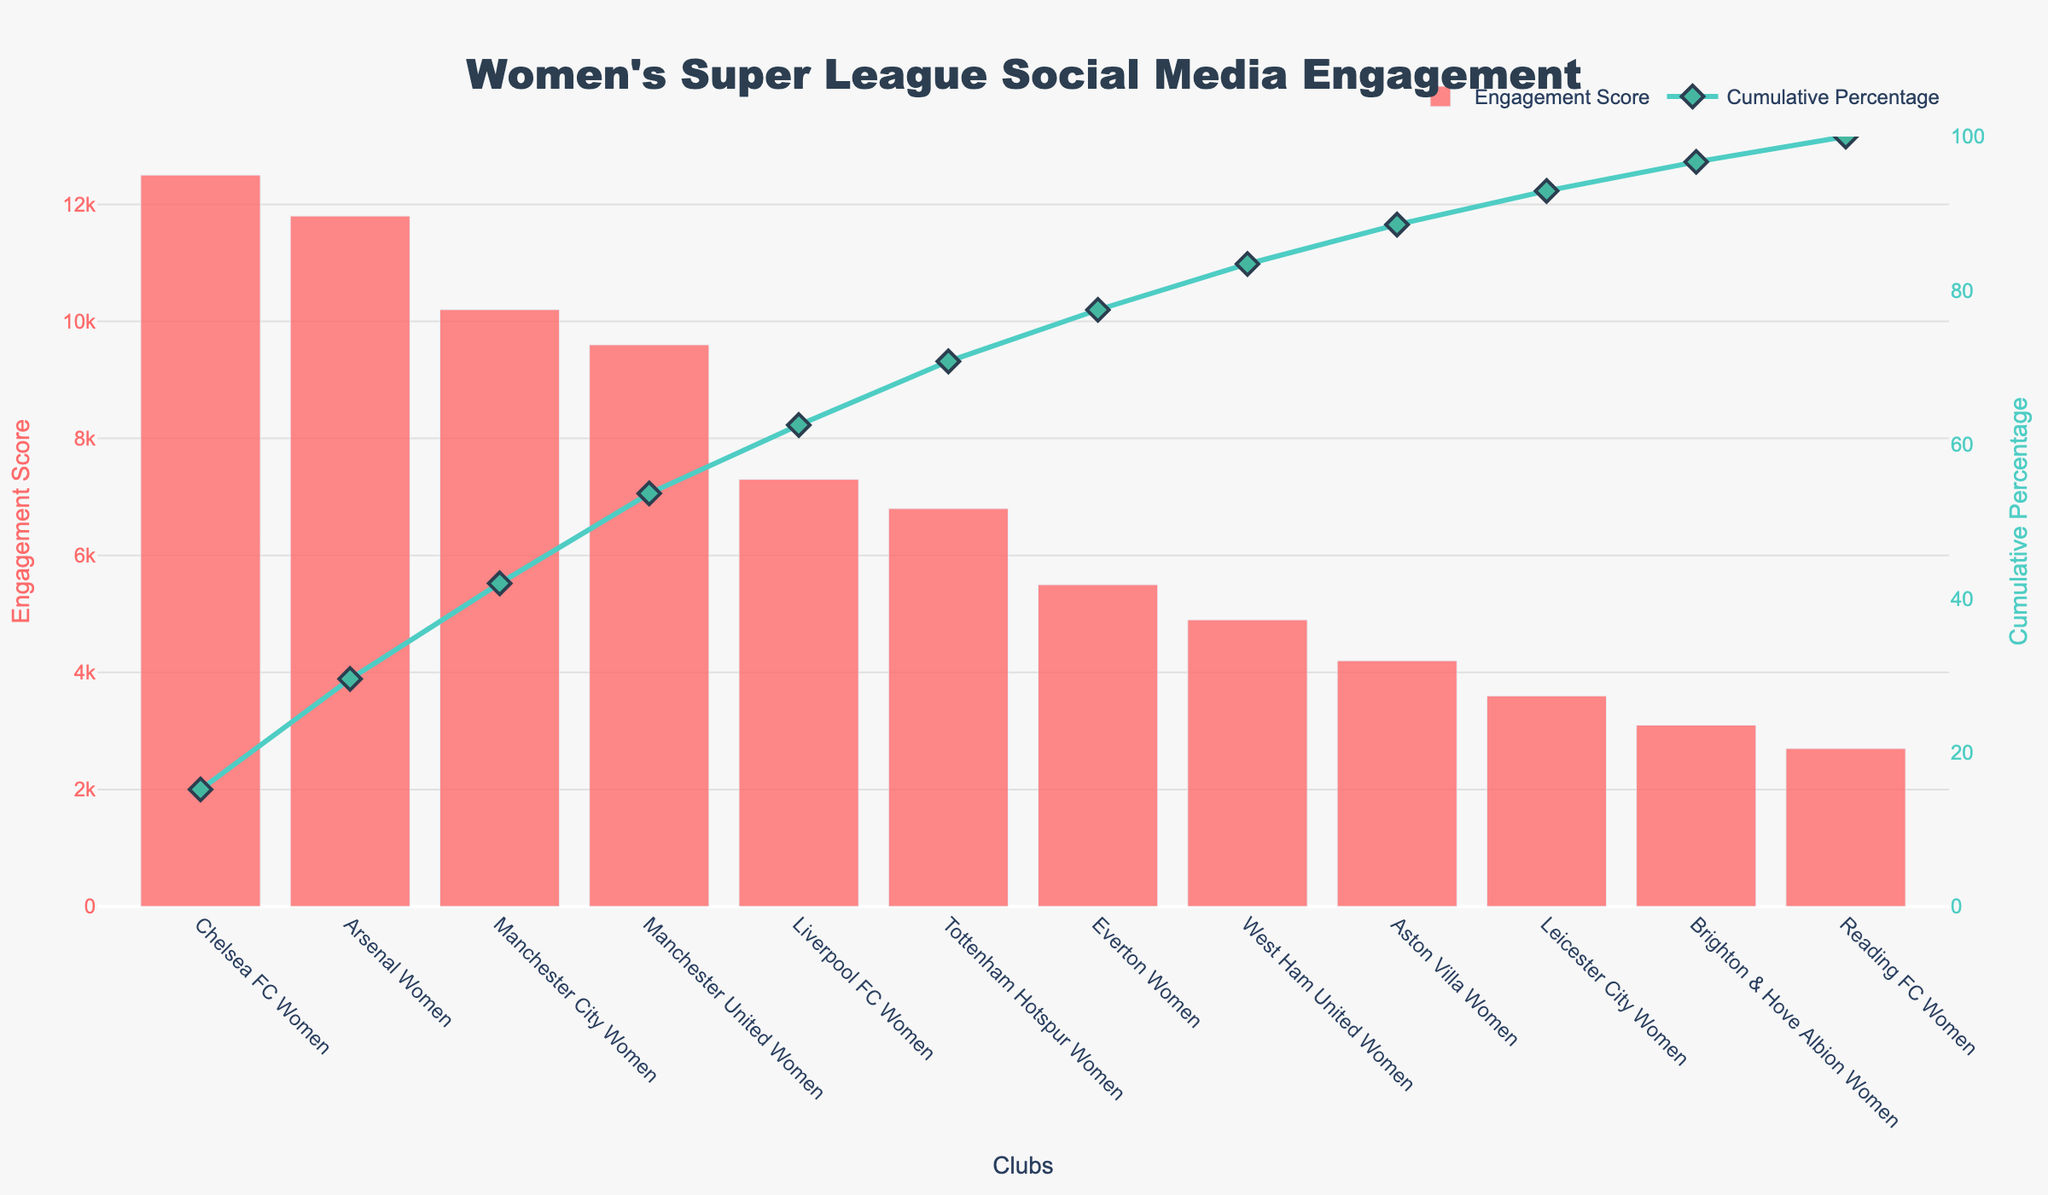How many clubs are included in the Pareto chart? The x-axis lists the club names, and we can count the number of unique names to find the total number of clubs.
Answer: 12 What is the title of the Pareto chart? The title is displayed at the top of the chart.
Answer: Women's Super League Social Media Engagement Which club has the highest social media engagement score? The bar with the highest value on the y-axis indicates the club with the highest score.
Answer: Chelsea FC Women How much higher is Arsenal Women's engagement score compared to Manchester United Women? Refer to the corresponding bars and subtract Manchester United Women's score from Arsenal Women's score (11800 - 9600).
Answer: 2200 What is the cumulative percentage for Manchester City Women? Locate Manchester City Women's position on the x-axis and refer to the cumulative percentage line associated with it.
Answer: Approximately 53.4% Which two clubs are closest in social media engagement score on the chart? Identify adjacent bars in height and compare their scores; Tottenham Hotspur Women and Liverpool FC Women are closest (6800 and 7300).
Answer: Tottenham Hotspur Women and Liverpool FC Women How many clubs have an engagement score of above 10,000? Count the bars with values exceeding the 10,000 mark.
Answer: 3 What is the cumulative percentage for clubs up to and including Manchester United Women? Add the scores of clubs up to Manchester United Women and calculate the cumulative percentage (12500 + 11800 + 10200 + 9600) / Total sum.
Answer: Approximately 93.9% Which club's engagement score, when added, brings the cumulative percentage closest to 75%? Continue summing the scores sequentially until reaching or nearly reaching 75%; Chelsea FC Women, Arsenal Women, and Manchester City Women combined account for this (12500 + 11800 + 10200).
Answer: Manchester City Women What color are the bars representing the engagement scores? Notice the consistent color of all bars on the figure.
Answer: Red 